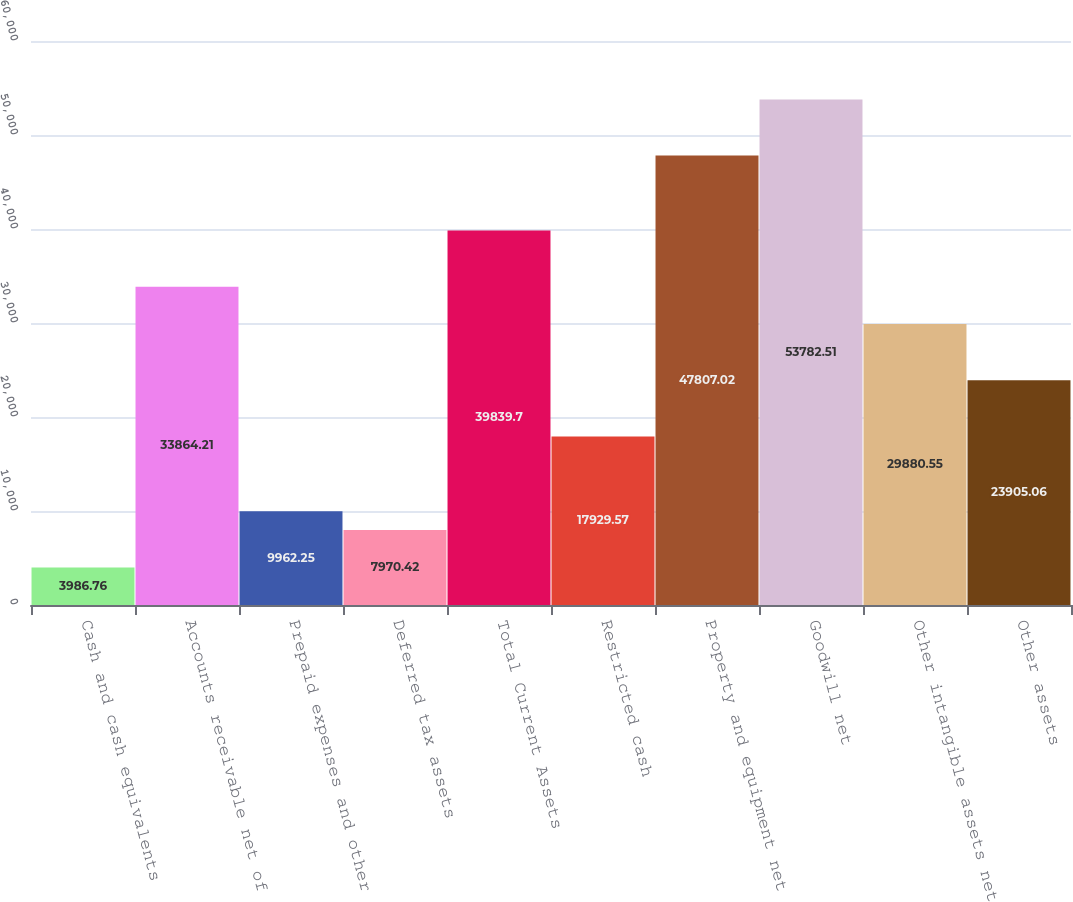Convert chart. <chart><loc_0><loc_0><loc_500><loc_500><bar_chart><fcel>Cash and cash equivalents<fcel>Accounts receivable net of<fcel>Prepaid expenses and other<fcel>Deferred tax assets<fcel>Total Current Assets<fcel>Restricted cash<fcel>Property and equipment net<fcel>Goodwill net<fcel>Other intangible assets net<fcel>Other assets<nl><fcel>3986.76<fcel>33864.2<fcel>9962.25<fcel>7970.42<fcel>39839.7<fcel>17929.6<fcel>47807<fcel>53782.5<fcel>29880.5<fcel>23905.1<nl></chart> 